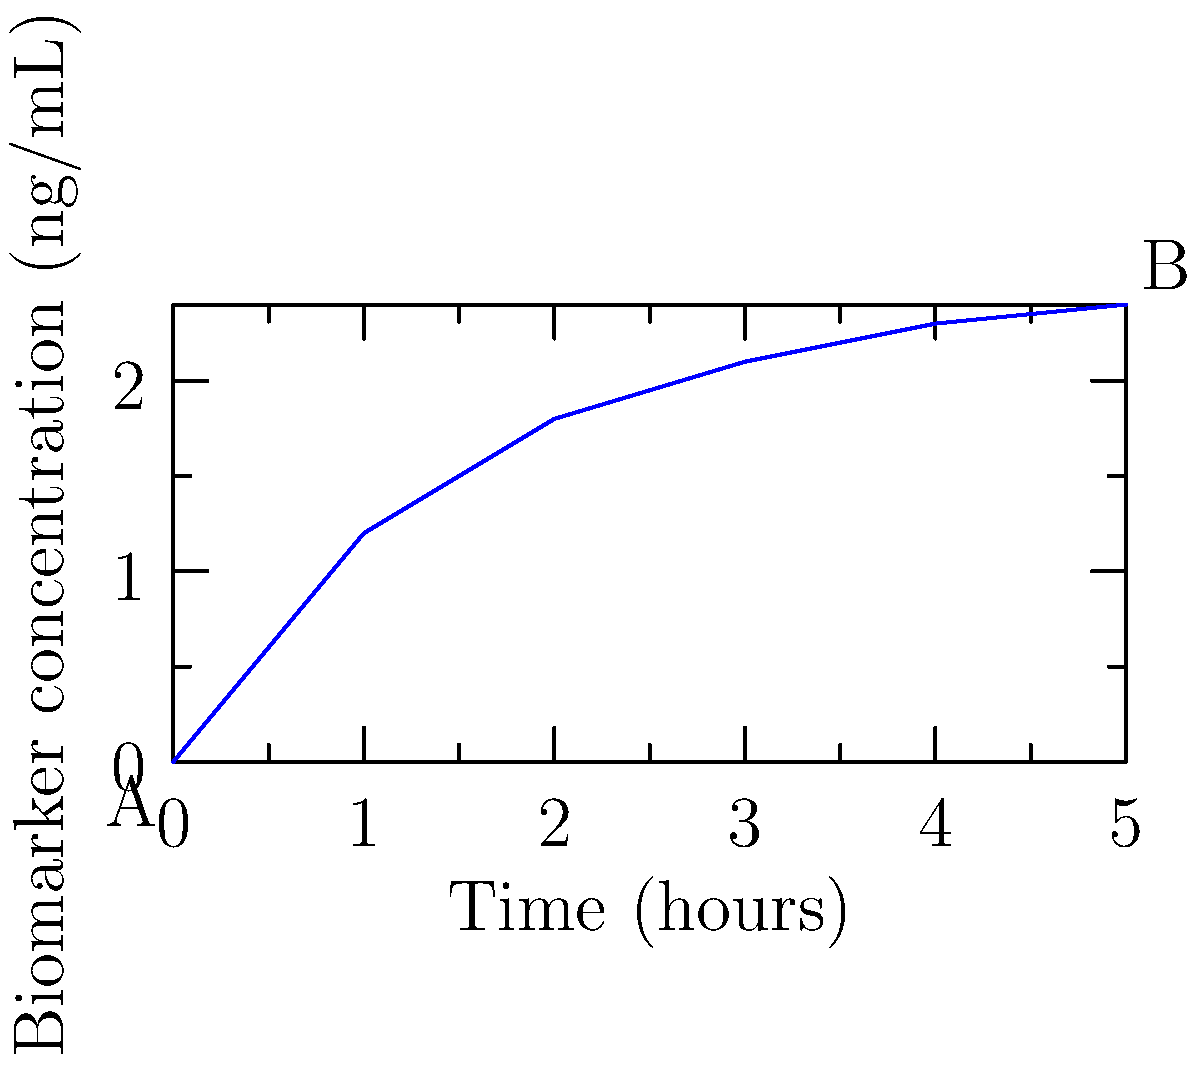The graph shows the concentration of a specific biomarker in a patient's blood over time after administering a contrast agent for medical imaging. If the threshold for detecting a rare disease is 2.0 ng/mL, at approximately what time (in hours) does the biomarker concentration first exceed this threshold? To answer this question, we need to follow these steps:

1. Identify the threshold concentration: 2.0 ng/mL

2. Examine the graph to find where the curve intersects the 2.0 ng/mL line:
   - At t = 0 hours, concentration ≈ 0 ng/mL
   - At t = 1 hour, concentration ≈ 1.2 ng/mL
   - At t = 2 hours, concentration ≈ 1.8 ng/mL
   - At t = 3 hours, concentration ≈ 2.1 ng/mL
   - At t = 4 hours, concentration ≈ 2.3 ng/mL
   - At t = 5 hours, concentration ≈ 2.4 ng/mL

3. Identify that the concentration first exceeds 2.0 ng/mL between 2 and 3 hours.

4. Estimate the time more precisely by linear interpolation:
   Let $y = mx + b$ where $m = \frac{2.1 - 1.8}{3 - 2} = 0.3$ per hour
   At 2 hours: $1.8 = 0.3(2) + b$, so $b = 1.2$
   Solve for x when y = 2.0: $2.0 = 0.3x + 1.2$
   $0.8 = 0.3x$
   $x = 0.8 / 0.3 ≈ 2.67$

5. Add this to the 2-hour mark: 2 + 0.67 = 2.67 hours

Therefore, the biomarker concentration first exceeds the threshold at approximately 2.67 hours.
Answer: 2.67 hours 